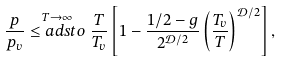Convert formula to latex. <formula><loc_0><loc_0><loc_500><loc_500>\frac { p } { p _ { v } } \stackrel { T \to \infty } { \leq a d s t o } \frac { T } { T _ { v } } \left [ 1 - \frac { 1 / 2 - g } { 2 ^ { \mathcal { D } / 2 } } \left ( \frac { T _ { v } } { T } \right ) ^ { \mathcal { D } / 2 } \right ] ,</formula> 